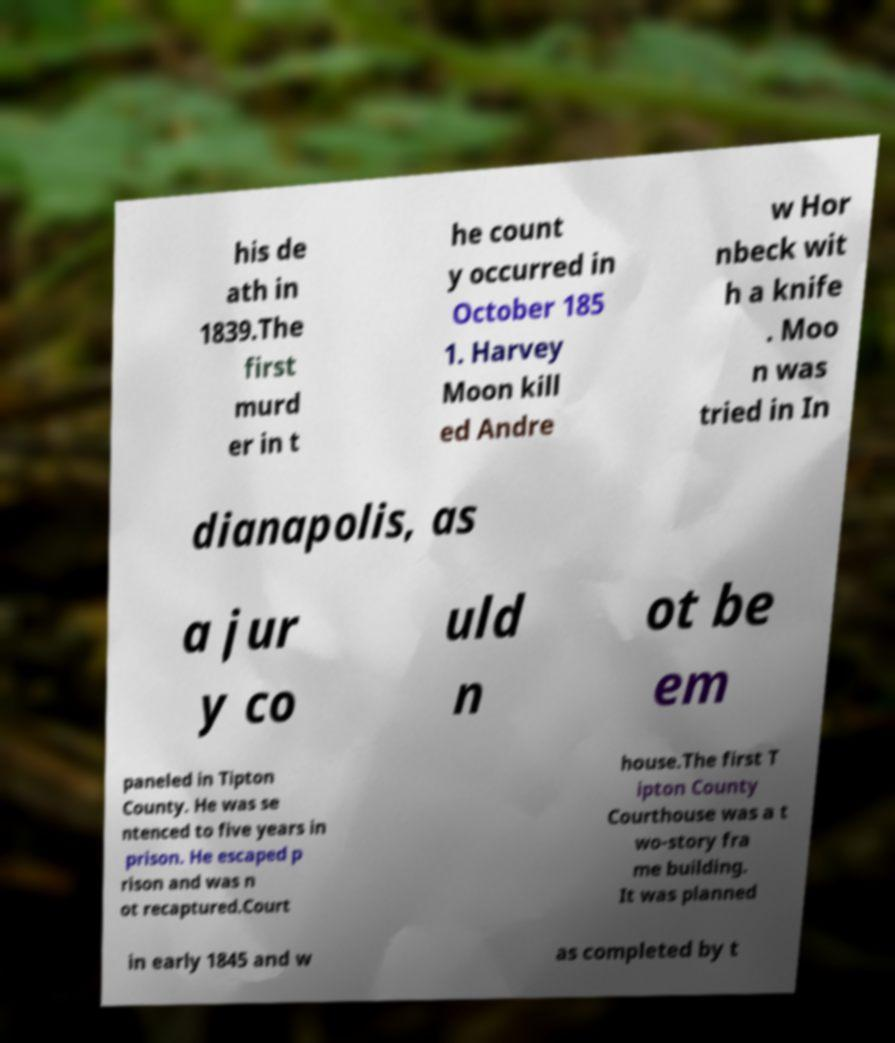What messages or text are displayed in this image? I need them in a readable, typed format. his de ath in 1839.The first murd er in t he count y occurred in October 185 1. Harvey Moon kill ed Andre w Hor nbeck wit h a knife . Moo n was tried in In dianapolis, as a jur y co uld n ot be em paneled in Tipton County. He was se ntenced to five years in prison. He escaped p rison and was n ot recaptured.Court house.The first T ipton County Courthouse was a t wo-story fra me building. It was planned in early 1845 and w as completed by t 